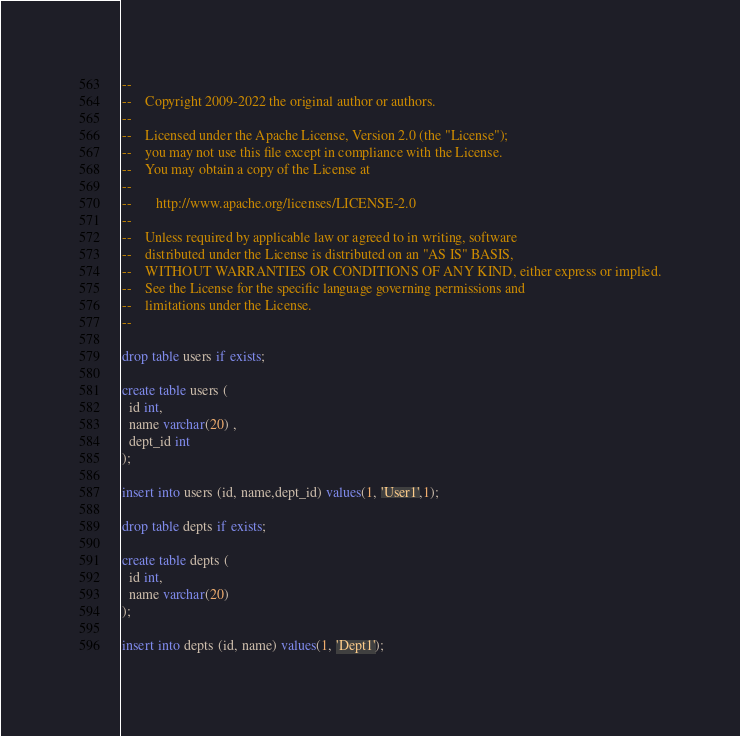<code> <loc_0><loc_0><loc_500><loc_500><_SQL_>--
--    Copyright 2009-2022 the original author or authors.
--
--    Licensed under the Apache License, Version 2.0 (the "License");
--    you may not use this file except in compliance with the License.
--    You may obtain a copy of the License at
--
--       http://www.apache.org/licenses/LICENSE-2.0
--
--    Unless required by applicable law or agreed to in writing, software
--    distributed under the License is distributed on an "AS IS" BASIS,
--    WITHOUT WARRANTIES OR CONDITIONS OF ANY KIND, either express or implied.
--    See the License for the specific language governing permissions and
--    limitations under the License.
--

drop table users if exists;

create table users (
  id int,
  name varchar(20) ,
  dept_id int
);

insert into users (id, name,dept_id) values(1, 'User1',1);

drop table depts if exists;

create table depts (
  id int,
  name varchar(20)
);

insert into depts (id, name) values(1, 'Dept1');

</code> 